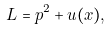<formula> <loc_0><loc_0><loc_500><loc_500>L = p ^ { 2 } + u ( x ) ,</formula> 